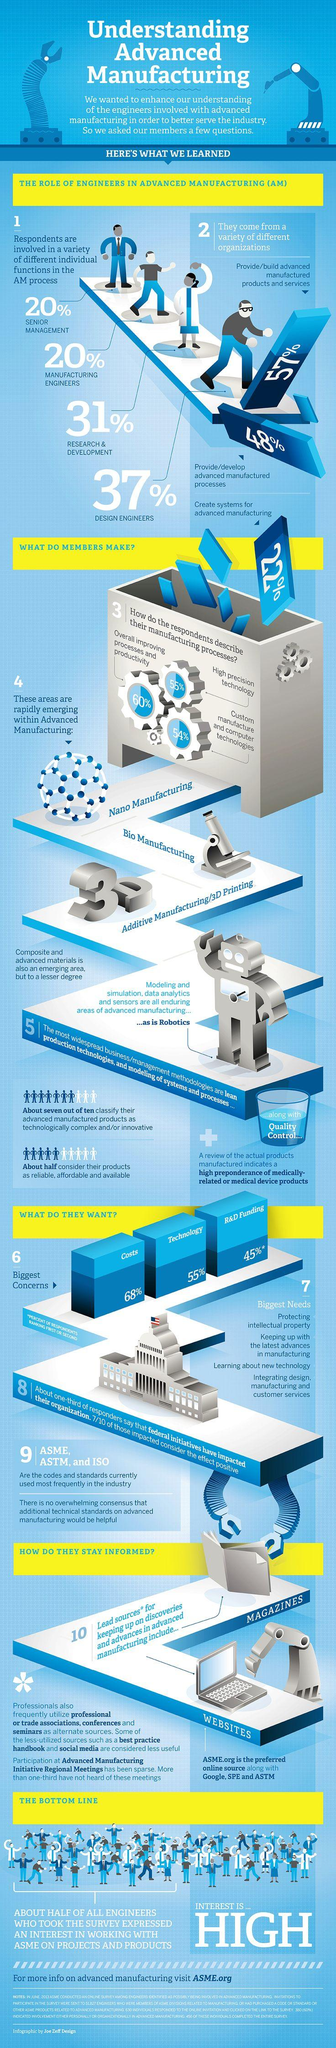Mention a couple of crucial points in this snapshot. There are three types of manufacturing processes listed. In the industry, the most commonly used codes and standards are 3. Results show that 55% of respondents describe their manufacturing process as high precision technology, with 60% and 54% of the respondents also falling into this category. The total percentage of engineers involved in the advanced manufacturing process is 108%. The total percentage of funding for technology and R&D is 100%. 